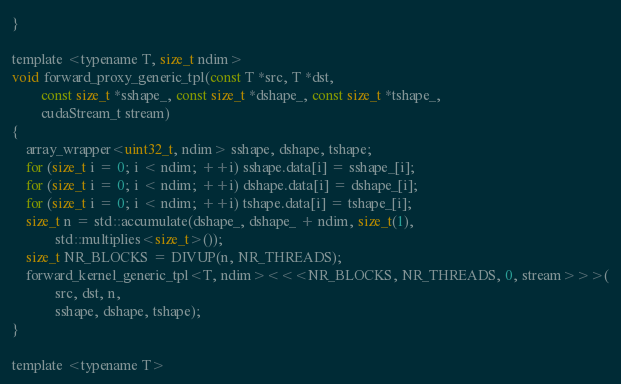<code> <loc_0><loc_0><loc_500><loc_500><_Cuda_>}

template <typename T, size_t ndim>
void forward_proxy_generic_tpl(const T *src, T *dst,
        const size_t *sshape_, const size_t *dshape_, const size_t *tshape_,
        cudaStream_t stream)
{
    array_wrapper<uint32_t, ndim> sshape, dshape, tshape;
    for (size_t i = 0; i < ndim; ++i) sshape.data[i] = sshape_[i];
    for (size_t i = 0; i < ndim; ++i) dshape.data[i] = dshape_[i];
    for (size_t i = 0; i < ndim; ++i) tshape.data[i] = tshape_[i];
    size_t n = std::accumulate(dshape_, dshape_ + ndim, size_t(1),
            std::multiplies<size_t>());
    size_t NR_BLOCKS = DIVUP(n, NR_THREADS);
    forward_kernel_generic_tpl<T, ndim><<<NR_BLOCKS, NR_THREADS, 0, stream>>>(
            src, dst, n,
            sshape, dshape, tshape);
}

template <typename T></code> 